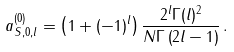Convert formula to latex. <formula><loc_0><loc_0><loc_500><loc_500>a _ { S , 0 , l } ^ { ( 0 ) } = \left ( 1 + ( - 1 ) ^ { l } \right ) \frac { 2 ^ { l } \Gamma ( l ) ^ { 2 } } { N \Gamma \left ( 2 l - 1 \right ) } \, .</formula> 